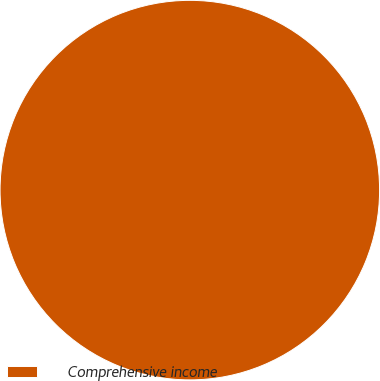Convert chart to OTSL. <chart><loc_0><loc_0><loc_500><loc_500><pie_chart><fcel>Comprehensive income<nl><fcel>100.0%<nl></chart> 